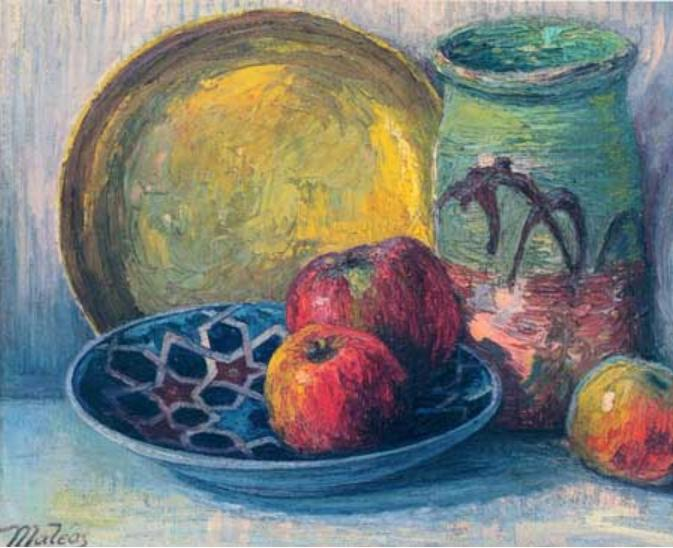Can we explore the significance of color usage in this painting? Absolutely! The use of color in this painting is quite significant and deliberate. The artist has chosen a palette that juxtaposes warm and cool colors to create a dynamic interplay. The yellow plate provides a warm, inviting backdrop, while the blue bowl adds depth and perhaps a sense of calm. The green vase introduces an earthy tone, connecting the objects to a more natural setting. The red apples not just punctuate the composition with their vibrancy but also draw the viewer's eye immediately, suggesting a focal point. This balanced color scheme enhances the aesthetic appeal and evokes a tranquil yet lively atmosphere. 